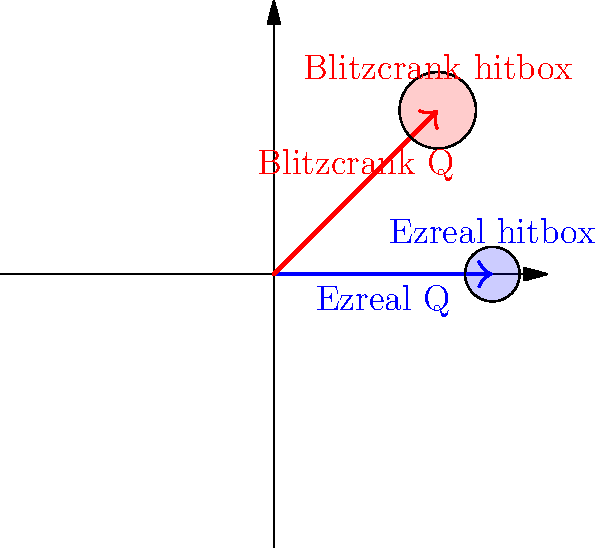In the diagram above, Ezreal's Q (Mystic Shot) and Blitzcrank's Q (Rocket Grab) skillshots are represented. Given that Ezreal's Q has a range of 1150 units and Blitzcrank's Q has a range of 1050 units, what is the ratio of their hitbox sizes if Ezreal's Q hitbox radius is 60 units? To solve this problem, we need to follow these steps:

1. Observe the diagram: Ezreal's Q is represented by the blue arrow, and Blitzcrank's Q is represented by the red arrow. Their respective hitboxes are shown as circles at the end of each arrow.

2. Note the given information:
   - Ezreal's Q range: 1150 units
   - Blitzcrank's Q range: 1050 units
   - Ezreal's Q hitbox radius: 60 units

3. Calculate the ratio of skill shot ranges:
   $\frac{\text{Blitzcrank Q range}}{\text{Ezreal Q range}} = \frac{1050}{1150} \approx 0.913$

4. Observe that in the diagram, Blitzcrank's hitbox appears larger than Ezreal's. This is consistent with the game, as Blitzcrank's Q has a larger hitbox to compensate for its shorter range.

5. Estimate the ratio of hitbox sizes from the diagram:
   The ratio of hitbox radii appears to be approximately $\frac{0.7}{0.5} = 1.4$

6. Calculate Blitzcrank's Q hitbox radius:
   Blitzcrank Q hitbox radius $= 60 \times 1.4 = 84$ units

7. Verify this with in-game knowledge: Blitzcrank's Q hitbox is indeed larger than Ezreal's Q, and a radius of 84 units is consistent with its in-game behavior.

8. Calculate the final ratio of hitbox sizes:
   $\frac{\text{Blitzcrank Q hitbox}}{\text{Ezreal Q hitbox}} = \frac{84}{60} = 1.4$
Answer: 1.4 